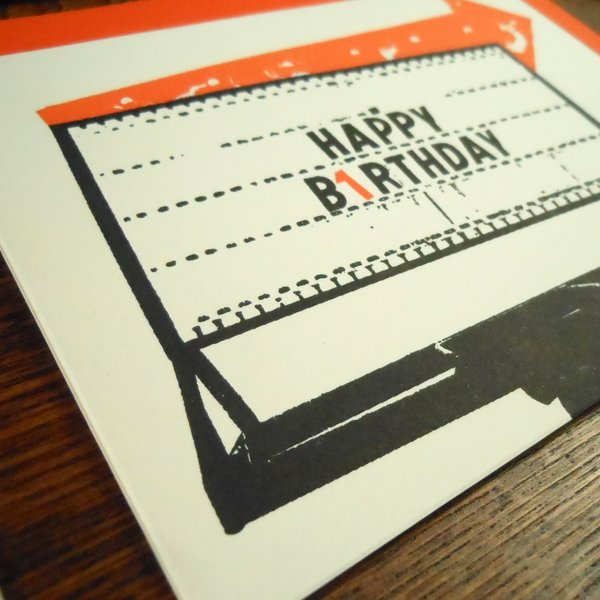Let's imagine this card was found in a time capsule. What story do you think it tells? Discovering this card in a time capsule would be like uncovering a fragment of personal history frozen in time. It would tell the story of a celebration marked with love and thoughtfulness. The vintage design would suggest that the sender was someone who cherished the past and valued nostalgic elements. The smudged text hints at the tactile and imperfect nature of communication before the digital age. The card could also represent a moment of connection between the sender and the recipient, a token of affection meant to be treasured. It serves as a reminder of how simple gestures, like a birthday card, hold sentimental value and timeless charm, even as decades pass. Does the typewriter-like aesthetic affect how you perceive the message written in the card? Absolutely. The typewriter-like aesthetic lends the message a unique authenticity and warmth. In an era dominated by digital communication, such a design feels personal and intimate. The imperfections like the smudges and slight misalignments make the card feel handcrafted and thoughtful, suggesting that extra care was taken in its creation. This tactile quality evokes a sense of nostalgia and sincerity, reinforcing the emotional impact of the 'HAPPY BIRTHDAY' message. It transforms the card from a simple greeting into a cherished keepsake, making the sentiment conveyed even more heartfelt and lasting. 